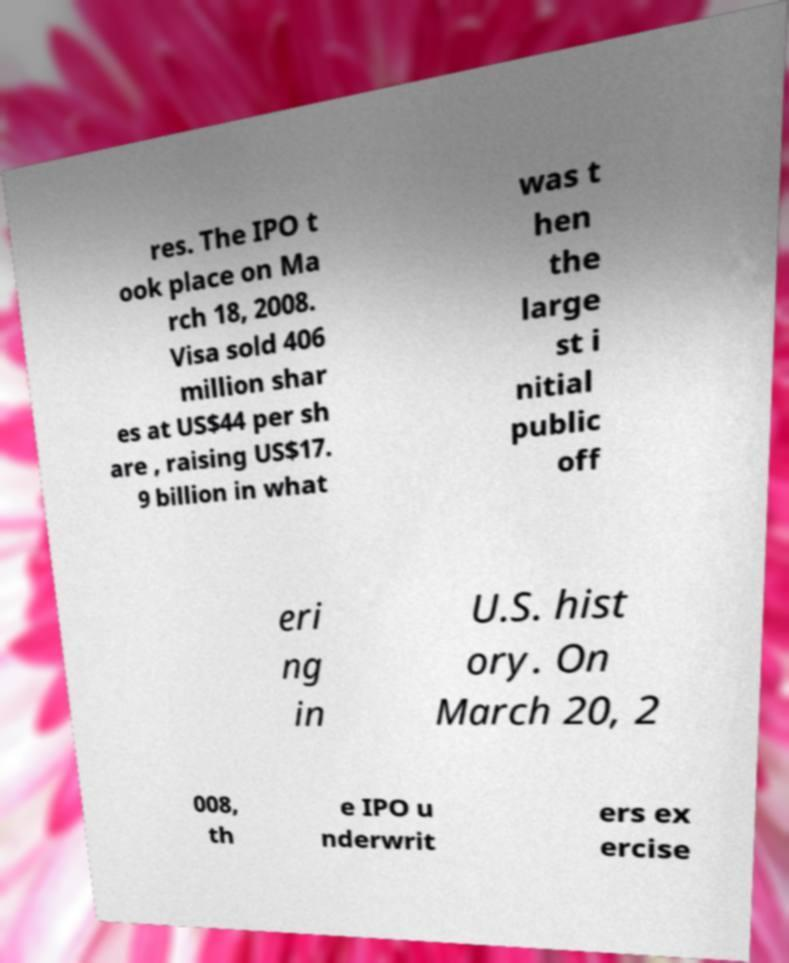Can you accurately transcribe the text from the provided image for me? res. The IPO t ook place on Ma rch 18, 2008. Visa sold 406 million shar es at US$44 per sh are , raising US$17. 9 billion in what was t hen the large st i nitial public off eri ng in U.S. hist ory. On March 20, 2 008, th e IPO u nderwrit ers ex ercise 